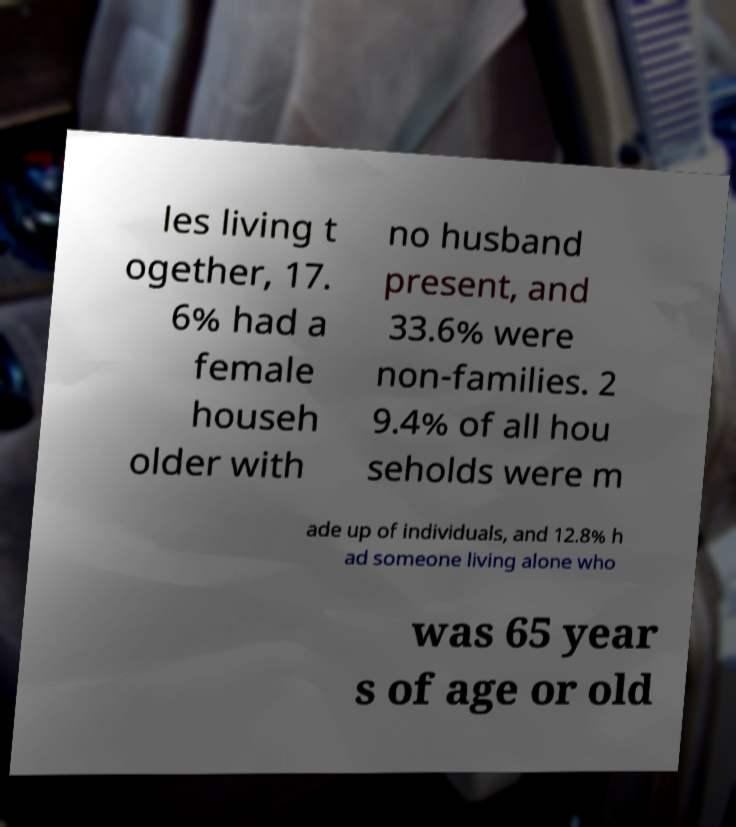I need the written content from this picture converted into text. Can you do that? les living t ogether, 17. 6% had a female househ older with no husband present, and 33.6% were non-families. 2 9.4% of all hou seholds were m ade up of individuals, and 12.8% h ad someone living alone who was 65 year s of age or old 